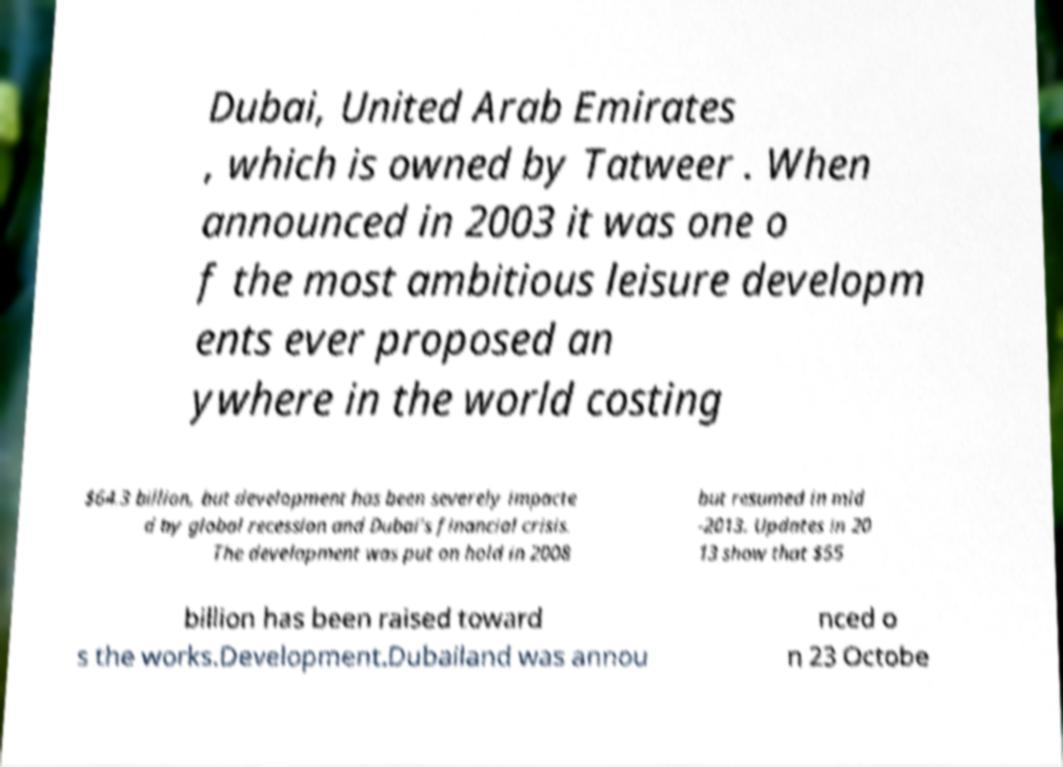Can you accurately transcribe the text from the provided image for me? Dubai, United Arab Emirates , which is owned by Tatweer . When announced in 2003 it was one o f the most ambitious leisure developm ents ever proposed an ywhere in the world costing $64.3 billion, but development has been severely impacte d by global recession and Dubai's financial crisis. The development was put on hold in 2008 but resumed in mid -2013. Updates in 20 13 show that $55 billion has been raised toward s the works.Development.Dubailand was annou nced o n 23 Octobe 